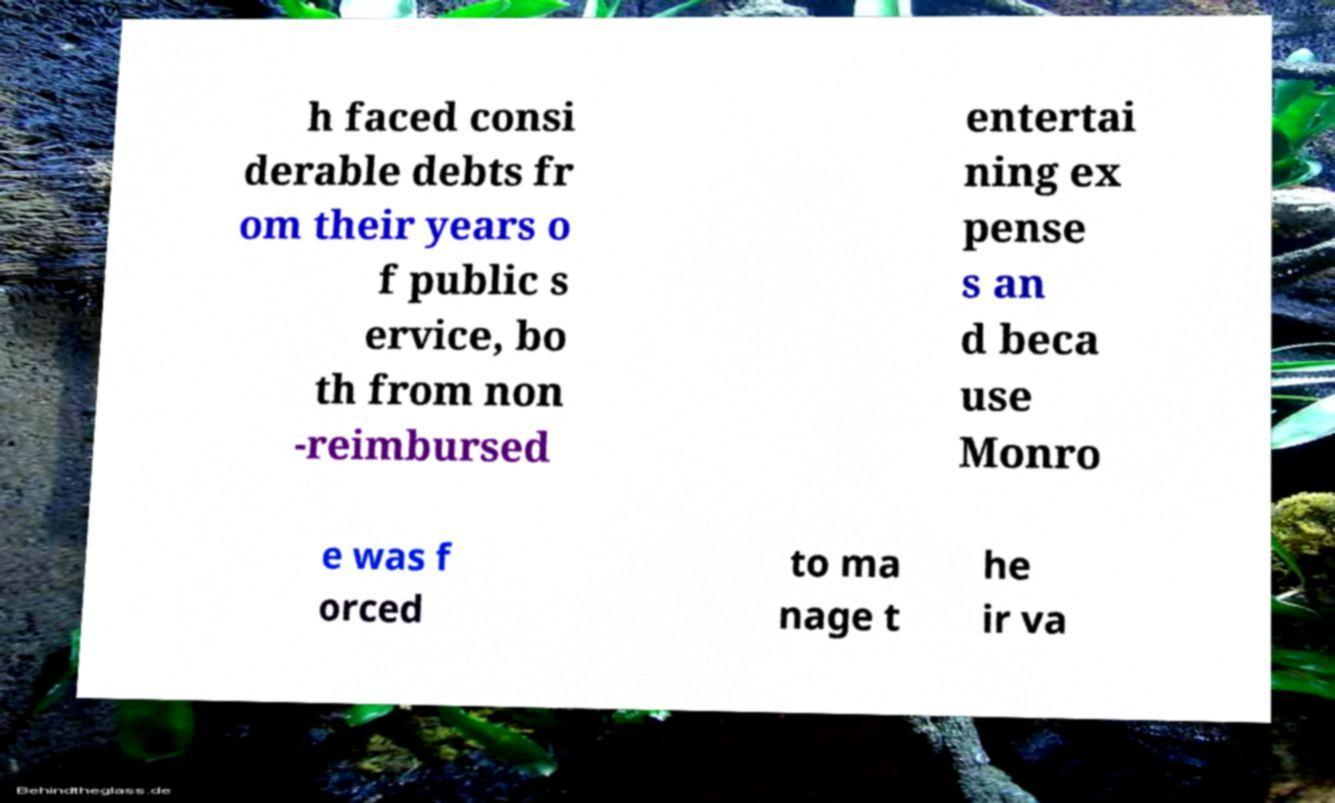Could you assist in decoding the text presented in this image and type it out clearly? h faced consi derable debts fr om their years o f public s ervice, bo th from non -reimbursed entertai ning ex pense s an d beca use Monro e was f orced to ma nage t he ir va 